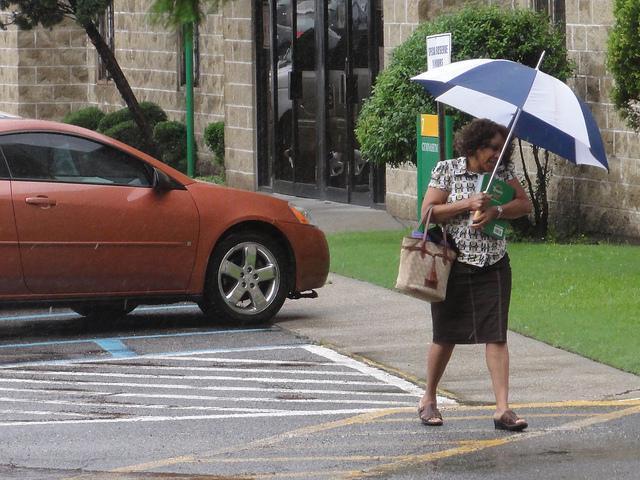What two primary colors have to be combined to get the color of the car?
Pick the right solution, then justify: 'Answer: answer
Rationale: rationale.'
Options: Blueyellow, redyellow, redblue, redwhite. Answer: redyellow.
Rationale: It is orange 